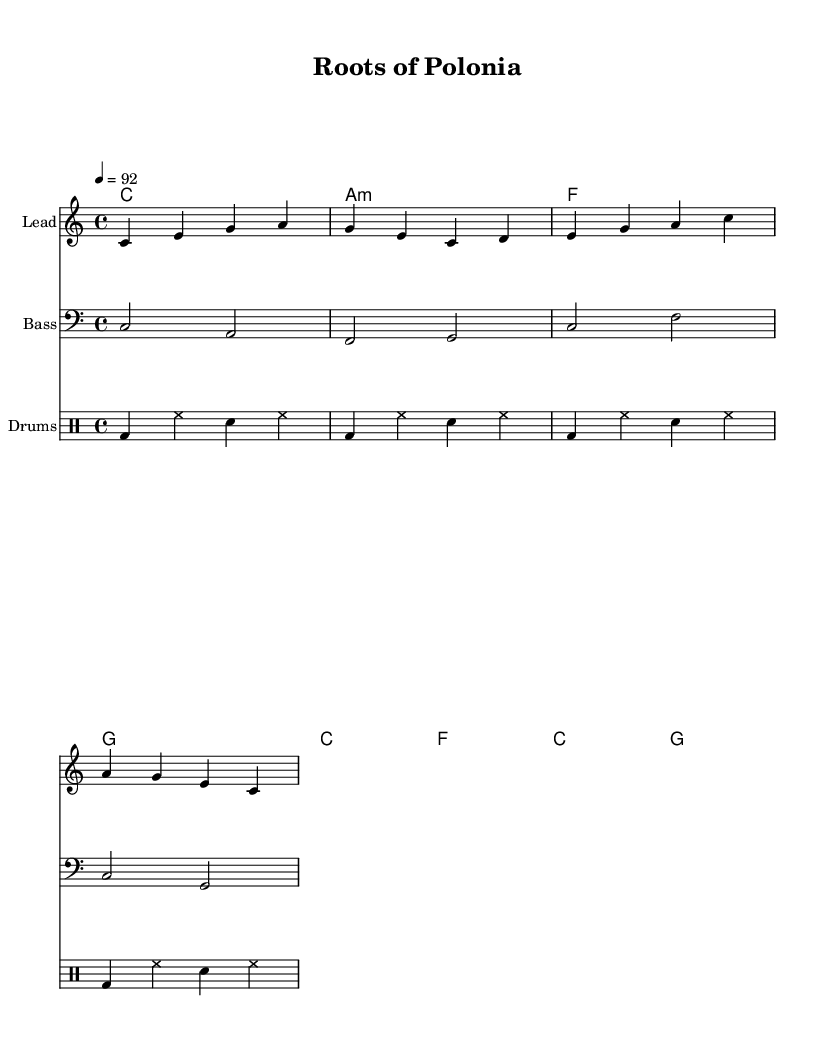What is the key signature of this music? The key signature is indicated at the beginning of the score, showing a C major scale. A C major scale has no sharps or flats.
Answer: C major What is the time signature of this music? The time signature is located at the beginning of the score and states 4/4, which means there are four beats in each measure and a quarter note gets one beat.
Answer: 4/4 What is the tempo marking for this piece? The tempo marking is found at the beginning and shows a metronome marking of 92, indicating the speed of the music.
Answer: 92 How many measures are in the melody? By counting the individual sections in the melody part, there are a total of four measures.
Answer: 4 What is the first chord of the piece? The first chord is shown in the chord names and indicates a C major chord, which is represented by its letter name.
Answer: C What type of rhythm pattern do the drums primarily use? The drum part indicates a consistent rhythm pattern of kick drum and snare in alternating measures, suggestive of a common reggae beat.
Answer: Reggae beat What cultural elements are represented in the lyrics? The lyrics evoke a sense of pride in heritage, referencing the Baltic and Tatra regions, which are significant to Polish culture.
Answer: Polish heritage 